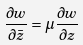Convert formula to latex. <formula><loc_0><loc_0><loc_500><loc_500>\frac { \partial w } { \partial \bar { z } } = \mu \frac { \partial w } { \partial z }</formula> 